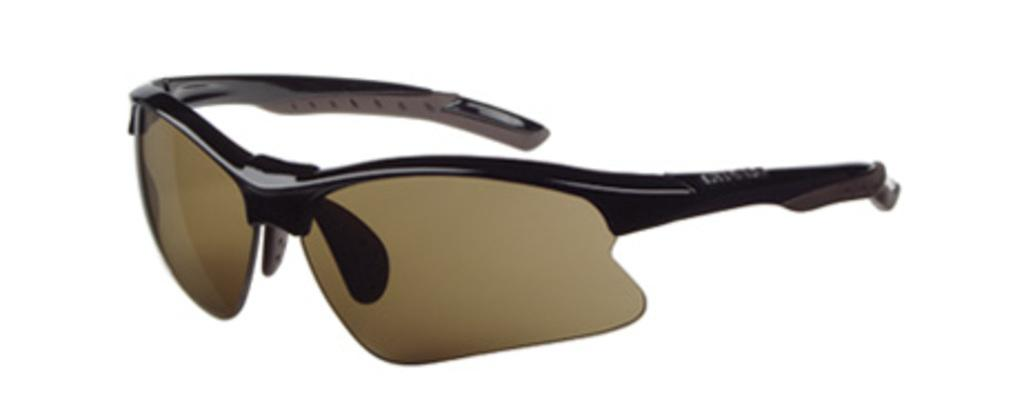What type of protective eyewear is visible in the image? There are goggles in the image. What colors are the goggles? The goggles are brown and black in color. On what surface are the goggles placed? The goggles are on a white surface. What actor is starting a hammer in the image? There is no actor or hammer present in the image; it only features goggles on a white surface. 